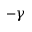Convert formula to latex. <formula><loc_0><loc_0><loc_500><loc_500>- \gamma</formula> 